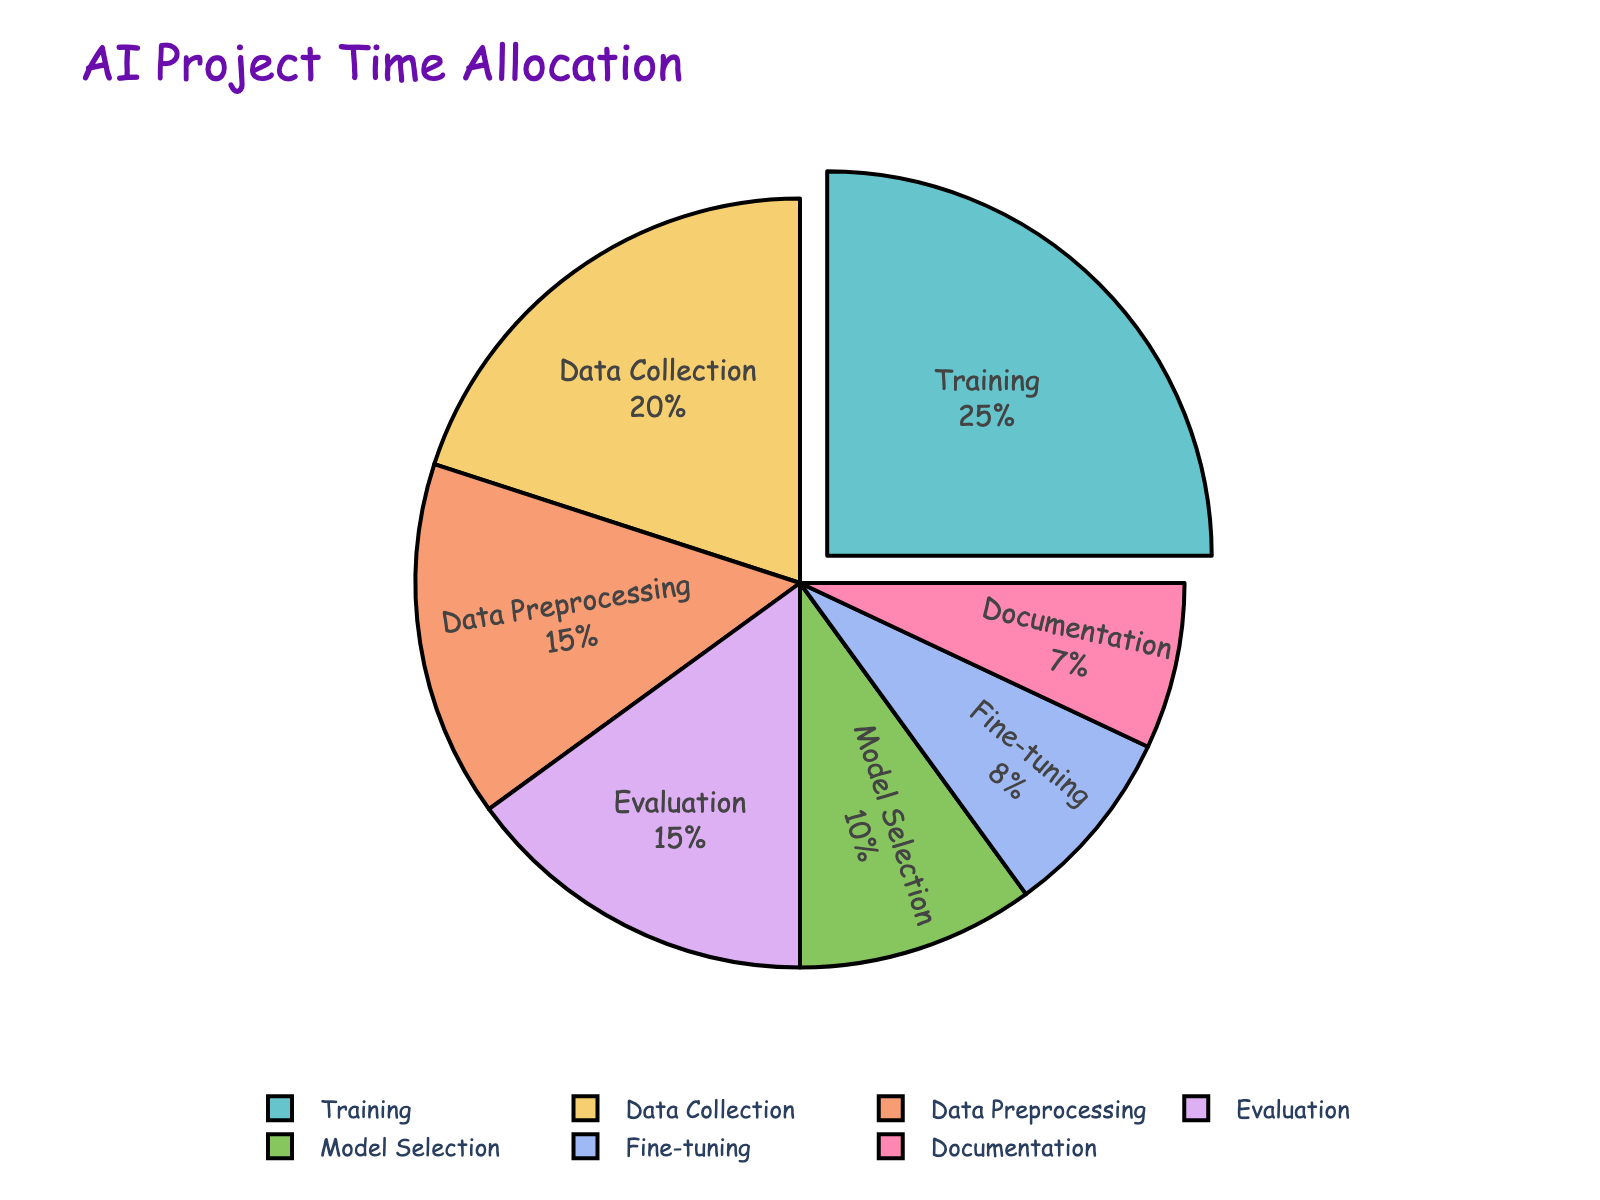Which stage takes up the most time in an AI project? The pie chart shows the different stages, and from the percentages, Training has the highest value at 25%.
Answer: Training Which two stages together account for more than 30% of the time spent? By inspecting the chart, Data Collection (20%) and Data Preprocessing (15%) together account for 35%, which is more than 30%.
Answer: Data Collection and Data Preprocessing What is the difference in time allocation between the Training stage and the Documentation stage? Training is allocated 25%, and Documentation is allocated 7%. The difference is 25% - 7% = 18%.
Answer: 18% Which stages combined take up less than 10% of the time allocation? Only Fine-tuning (8%) and Documentation (7%) individually take less than 10%, but combined they account for more than 10%. No individual stage takes less than 10%.
Answer: None What percentage of time is spent on stages related to handling data (Data Collection and Data Preprocessing)? Data Collection is 20%, and Data Preprocessing is 15%. So, the total is 20% + 15% = 35%.
Answer: 35% How does the time allocation for Model Selection compare with that of Fine-tuning? Model Selection takes 10%, whereas Fine-tuning takes 8%. Model Selection has a 2% higher allocation than Fine-tuning.
Answer: Model Selection has 2% more time than Fine-tuning What's the combined time allocation for stages that take exactly 15% each? Both Data Preprocessing and Evaluation stages take 15% each. Combined, they make 15% + 15% = 30%.
Answer: 30% If the Training stage is reduced by half, which stage will then have the highest time allocation? If Training is reduced by half, it becomes 12.5%. The highest will then be Data Collection at 20%.
Answer: Data Collection What is the percentage difference between the Data Collection and the Fine-tuning stages? Data Collection is 20%, and Fine-tuning is 8%. The difference is 20% - 8% = 12%.
Answer: 12% If you added a new stage called "Deployment" with 10%, how much time would the current "Training" stage represent out of the total? The original total is 100%. Adding a new stage at 10% makes the new total 110%. Therefore, the Training stage would be (25/110)×100% ≈ 22.73%.
Answer: 22.73% 